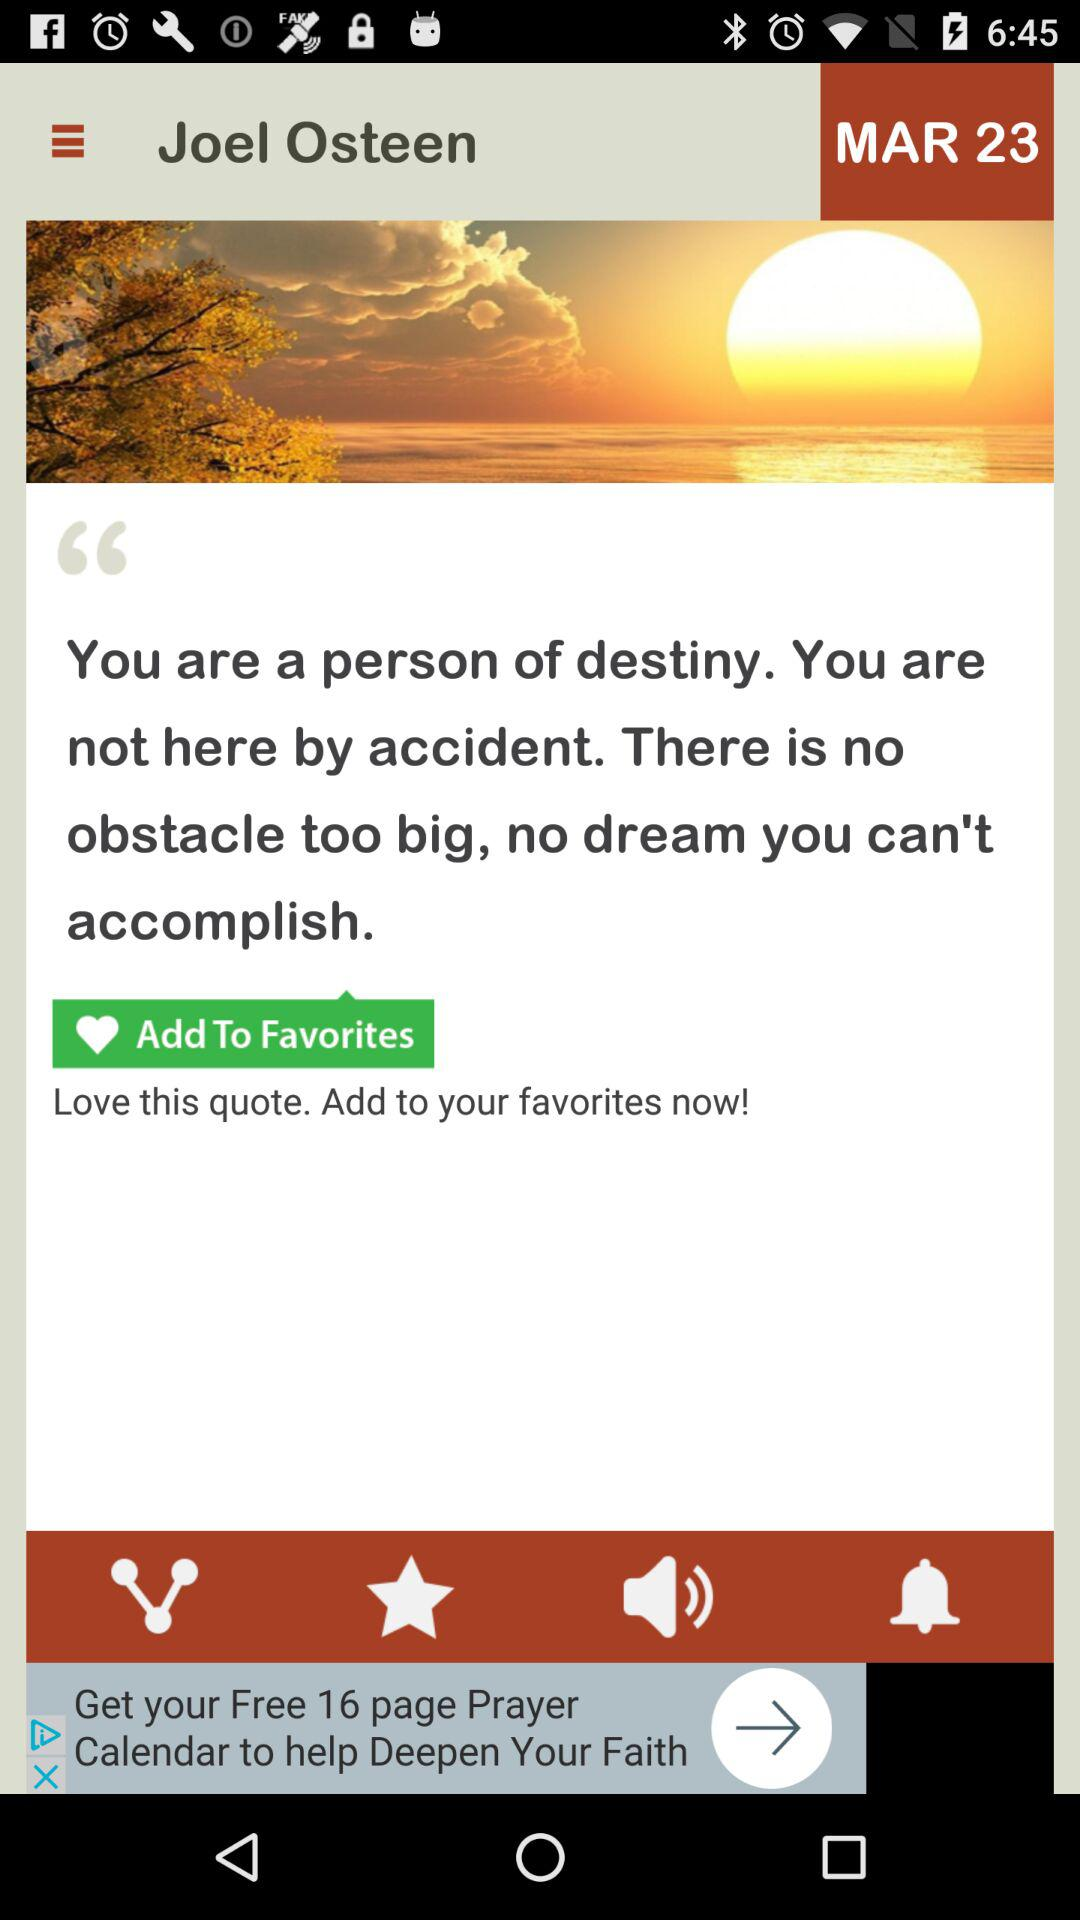Who is Joel Osteen?
When the provided information is insufficient, respond with <no answer>. <no answer> 